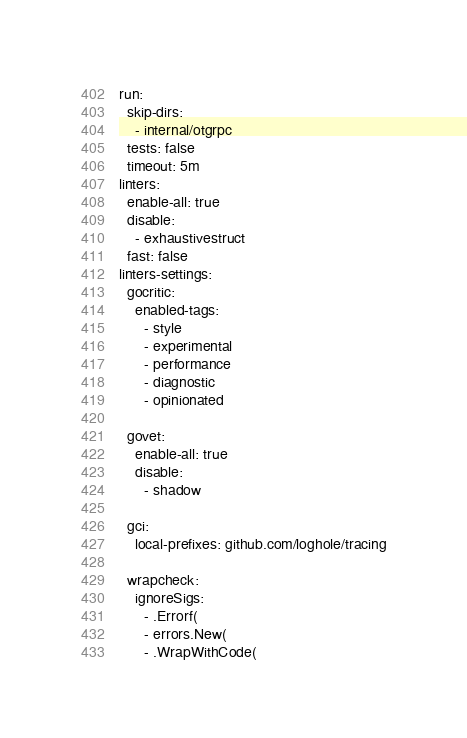<code> <loc_0><loc_0><loc_500><loc_500><_YAML_>run:
  skip-dirs:
    - internal/otgrpc
  tests: false
  timeout: 5m
linters:
  enable-all: true
  disable:
    - exhaustivestruct
  fast: false
linters-settings:
  gocritic:
    enabled-tags:
      - style
      - experimental
      - performance
      - diagnostic
      - opinionated

  govet:
    enable-all: true
    disable:
      - shadow

  gci:
    local-prefixes: github.com/loghole/tracing

  wrapcheck:
    ignoreSigs:
      - .Errorf(
      - errors.New(
      - .WrapWithCode(
</code> 